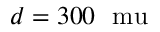<formula> <loc_0><loc_0><loc_500><loc_500>d = 3 0 0 \ m u</formula> 